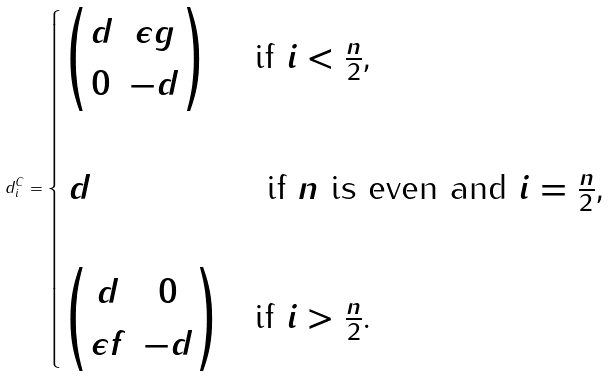<formula> <loc_0><loc_0><loc_500><loc_500>d ^ { C } _ { i } = \begin{cases} \begin{pmatrix} d & \epsilon g \\ 0 & - d \end{pmatrix} & \text {if $i < \frac{n}{2}$,} \\ & \\ \, d & \text { if $n$ is even and $i = \frac{n}{2}$,} \\ & \\ \begin{pmatrix} d & 0 \\ \epsilon f & - d \end{pmatrix} & \text {if $i > \frac{n}{2}$.} \\ \end{cases}</formula> 